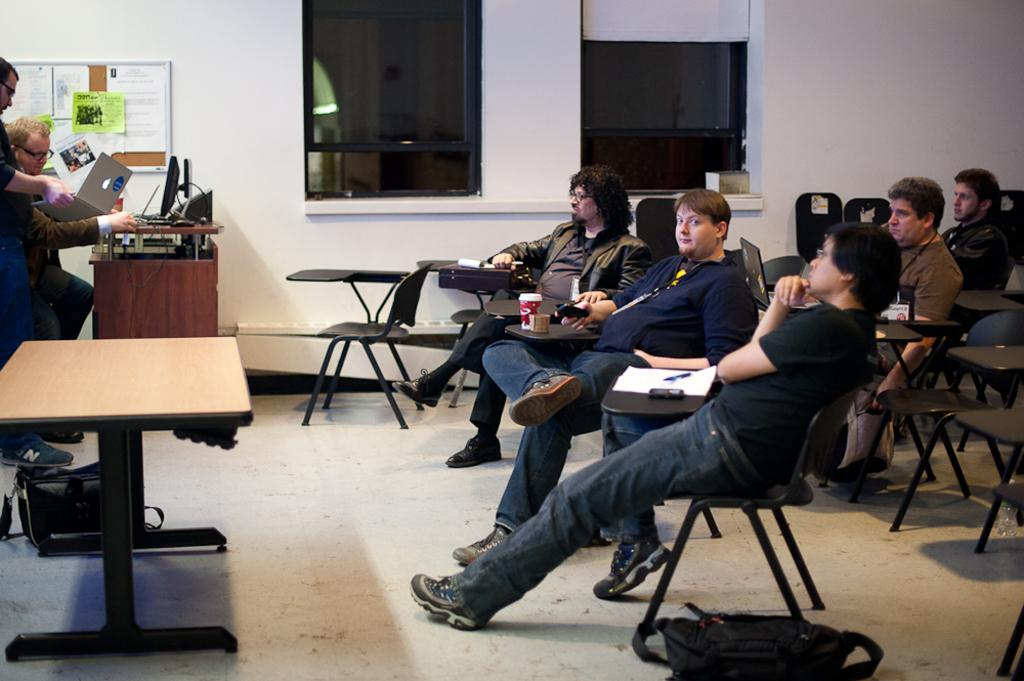What is happening in the image? There is a group of people in the image, and they are sitting in chairs. Can you describe the arrangement of the people in the image? There are two persons in front of the group. What type of steel is being used to make the vase in the image? There is no vase present in the image, so it is not possible to determine what type of steel might be used. 